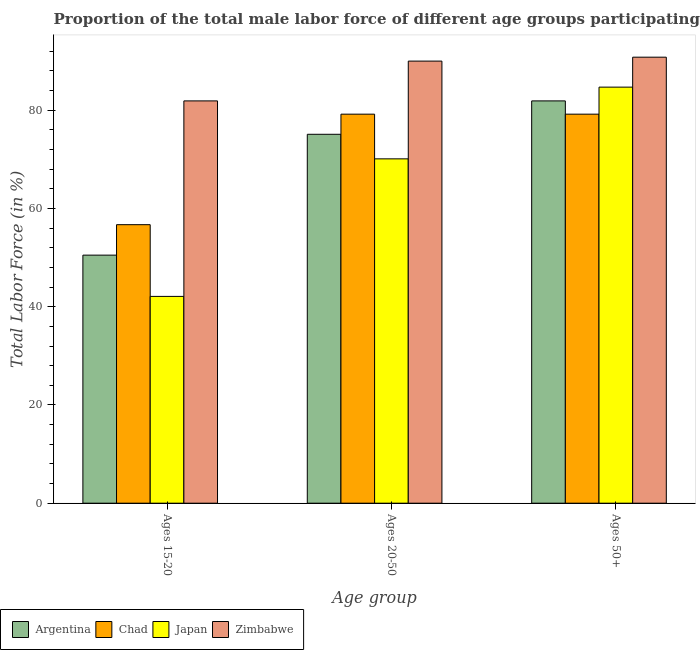How many groups of bars are there?
Provide a short and direct response. 3. Are the number of bars per tick equal to the number of legend labels?
Your answer should be compact. Yes. Are the number of bars on each tick of the X-axis equal?
Provide a succinct answer. Yes. What is the label of the 2nd group of bars from the left?
Provide a succinct answer. Ages 20-50. What is the percentage of male labor force above age 50 in Japan?
Keep it short and to the point. 84.7. Across all countries, what is the maximum percentage of male labor force within the age group 20-50?
Offer a very short reply. 90. Across all countries, what is the minimum percentage of male labor force within the age group 20-50?
Offer a very short reply. 70.1. In which country was the percentage of male labor force above age 50 maximum?
Provide a succinct answer. Zimbabwe. What is the total percentage of male labor force within the age group 15-20 in the graph?
Offer a terse response. 231.2. What is the difference between the percentage of male labor force above age 50 in Japan and that in Zimbabwe?
Your answer should be very brief. -6.1. What is the difference between the percentage of male labor force within the age group 15-20 in Zimbabwe and the percentage of male labor force within the age group 20-50 in Chad?
Provide a succinct answer. 2.7. What is the average percentage of male labor force within the age group 15-20 per country?
Ensure brevity in your answer.  57.8. What is the difference between the percentage of male labor force above age 50 and percentage of male labor force within the age group 20-50 in Japan?
Provide a succinct answer. 14.6. What is the ratio of the percentage of male labor force within the age group 15-20 in Argentina to that in Chad?
Ensure brevity in your answer.  0.89. Is the percentage of male labor force within the age group 20-50 in Argentina less than that in Japan?
Offer a very short reply. No. Is the difference between the percentage of male labor force within the age group 15-20 in Argentina and Chad greater than the difference between the percentage of male labor force above age 50 in Argentina and Chad?
Make the answer very short. No. What is the difference between the highest and the second highest percentage of male labor force above age 50?
Your answer should be compact. 6.1. What is the difference between the highest and the lowest percentage of male labor force above age 50?
Offer a very short reply. 11.6. In how many countries, is the percentage of male labor force within the age group 15-20 greater than the average percentage of male labor force within the age group 15-20 taken over all countries?
Your answer should be compact. 1. Is the sum of the percentage of male labor force within the age group 20-50 in Chad and Zimbabwe greater than the maximum percentage of male labor force above age 50 across all countries?
Provide a short and direct response. Yes. What does the 4th bar from the left in Ages 20-50 represents?
Your answer should be compact. Zimbabwe. What does the 1st bar from the right in Ages 15-20 represents?
Give a very brief answer. Zimbabwe. How many bars are there?
Your answer should be very brief. 12. Are all the bars in the graph horizontal?
Provide a short and direct response. No. How many countries are there in the graph?
Your response must be concise. 4. Are the values on the major ticks of Y-axis written in scientific E-notation?
Give a very brief answer. No. Does the graph contain grids?
Keep it short and to the point. No. Where does the legend appear in the graph?
Make the answer very short. Bottom left. What is the title of the graph?
Offer a very short reply. Proportion of the total male labor force of different age groups participating in production in 2014. What is the label or title of the X-axis?
Provide a succinct answer. Age group. What is the label or title of the Y-axis?
Provide a short and direct response. Total Labor Force (in %). What is the Total Labor Force (in %) in Argentina in Ages 15-20?
Your answer should be compact. 50.5. What is the Total Labor Force (in %) of Chad in Ages 15-20?
Your response must be concise. 56.7. What is the Total Labor Force (in %) of Japan in Ages 15-20?
Provide a succinct answer. 42.1. What is the Total Labor Force (in %) of Zimbabwe in Ages 15-20?
Provide a succinct answer. 81.9. What is the Total Labor Force (in %) in Argentina in Ages 20-50?
Give a very brief answer. 75.1. What is the Total Labor Force (in %) of Chad in Ages 20-50?
Your response must be concise. 79.2. What is the Total Labor Force (in %) in Japan in Ages 20-50?
Offer a very short reply. 70.1. What is the Total Labor Force (in %) of Zimbabwe in Ages 20-50?
Keep it short and to the point. 90. What is the Total Labor Force (in %) of Argentina in Ages 50+?
Keep it short and to the point. 81.9. What is the Total Labor Force (in %) in Chad in Ages 50+?
Give a very brief answer. 79.2. What is the Total Labor Force (in %) in Japan in Ages 50+?
Your answer should be very brief. 84.7. What is the Total Labor Force (in %) of Zimbabwe in Ages 50+?
Provide a short and direct response. 90.8. Across all Age group, what is the maximum Total Labor Force (in %) of Argentina?
Make the answer very short. 81.9. Across all Age group, what is the maximum Total Labor Force (in %) in Chad?
Keep it short and to the point. 79.2. Across all Age group, what is the maximum Total Labor Force (in %) of Japan?
Your answer should be very brief. 84.7. Across all Age group, what is the maximum Total Labor Force (in %) in Zimbabwe?
Ensure brevity in your answer.  90.8. Across all Age group, what is the minimum Total Labor Force (in %) in Argentina?
Give a very brief answer. 50.5. Across all Age group, what is the minimum Total Labor Force (in %) in Chad?
Ensure brevity in your answer.  56.7. Across all Age group, what is the minimum Total Labor Force (in %) in Japan?
Offer a terse response. 42.1. Across all Age group, what is the minimum Total Labor Force (in %) of Zimbabwe?
Offer a terse response. 81.9. What is the total Total Labor Force (in %) of Argentina in the graph?
Make the answer very short. 207.5. What is the total Total Labor Force (in %) in Chad in the graph?
Provide a succinct answer. 215.1. What is the total Total Labor Force (in %) of Japan in the graph?
Provide a succinct answer. 196.9. What is the total Total Labor Force (in %) in Zimbabwe in the graph?
Ensure brevity in your answer.  262.7. What is the difference between the Total Labor Force (in %) in Argentina in Ages 15-20 and that in Ages 20-50?
Ensure brevity in your answer.  -24.6. What is the difference between the Total Labor Force (in %) of Chad in Ages 15-20 and that in Ages 20-50?
Provide a succinct answer. -22.5. What is the difference between the Total Labor Force (in %) in Japan in Ages 15-20 and that in Ages 20-50?
Your answer should be very brief. -28. What is the difference between the Total Labor Force (in %) of Zimbabwe in Ages 15-20 and that in Ages 20-50?
Keep it short and to the point. -8.1. What is the difference between the Total Labor Force (in %) of Argentina in Ages 15-20 and that in Ages 50+?
Provide a short and direct response. -31.4. What is the difference between the Total Labor Force (in %) in Chad in Ages 15-20 and that in Ages 50+?
Your response must be concise. -22.5. What is the difference between the Total Labor Force (in %) in Japan in Ages 15-20 and that in Ages 50+?
Your answer should be very brief. -42.6. What is the difference between the Total Labor Force (in %) of Chad in Ages 20-50 and that in Ages 50+?
Offer a terse response. 0. What is the difference between the Total Labor Force (in %) in Japan in Ages 20-50 and that in Ages 50+?
Give a very brief answer. -14.6. What is the difference between the Total Labor Force (in %) of Argentina in Ages 15-20 and the Total Labor Force (in %) of Chad in Ages 20-50?
Provide a short and direct response. -28.7. What is the difference between the Total Labor Force (in %) in Argentina in Ages 15-20 and the Total Labor Force (in %) in Japan in Ages 20-50?
Keep it short and to the point. -19.6. What is the difference between the Total Labor Force (in %) in Argentina in Ages 15-20 and the Total Labor Force (in %) in Zimbabwe in Ages 20-50?
Provide a succinct answer. -39.5. What is the difference between the Total Labor Force (in %) in Chad in Ages 15-20 and the Total Labor Force (in %) in Zimbabwe in Ages 20-50?
Provide a succinct answer. -33.3. What is the difference between the Total Labor Force (in %) of Japan in Ages 15-20 and the Total Labor Force (in %) of Zimbabwe in Ages 20-50?
Your answer should be very brief. -47.9. What is the difference between the Total Labor Force (in %) of Argentina in Ages 15-20 and the Total Labor Force (in %) of Chad in Ages 50+?
Keep it short and to the point. -28.7. What is the difference between the Total Labor Force (in %) of Argentina in Ages 15-20 and the Total Labor Force (in %) of Japan in Ages 50+?
Your response must be concise. -34.2. What is the difference between the Total Labor Force (in %) in Argentina in Ages 15-20 and the Total Labor Force (in %) in Zimbabwe in Ages 50+?
Give a very brief answer. -40.3. What is the difference between the Total Labor Force (in %) of Chad in Ages 15-20 and the Total Labor Force (in %) of Zimbabwe in Ages 50+?
Your answer should be compact. -34.1. What is the difference between the Total Labor Force (in %) in Japan in Ages 15-20 and the Total Labor Force (in %) in Zimbabwe in Ages 50+?
Your answer should be compact. -48.7. What is the difference between the Total Labor Force (in %) of Argentina in Ages 20-50 and the Total Labor Force (in %) of Japan in Ages 50+?
Provide a succinct answer. -9.6. What is the difference between the Total Labor Force (in %) of Argentina in Ages 20-50 and the Total Labor Force (in %) of Zimbabwe in Ages 50+?
Your answer should be compact. -15.7. What is the difference between the Total Labor Force (in %) in Chad in Ages 20-50 and the Total Labor Force (in %) in Japan in Ages 50+?
Make the answer very short. -5.5. What is the difference between the Total Labor Force (in %) of Chad in Ages 20-50 and the Total Labor Force (in %) of Zimbabwe in Ages 50+?
Give a very brief answer. -11.6. What is the difference between the Total Labor Force (in %) of Japan in Ages 20-50 and the Total Labor Force (in %) of Zimbabwe in Ages 50+?
Give a very brief answer. -20.7. What is the average Total Labor Force (in %) in Argentina per Age group?
Make the answer very short. 69.17. What is the average Total Labor Force (in %) in Chad per Age group?
Offer a very short reply. 71.7. What is the average Total Labor Force (in %) in Japan per Age group?
Make the answer very short. 65.63. What is the average Total Labor Force (in %) in Zimbabwe per Age group?
Your response must be concise. 87.57. What is the difference between the Total Labor Force (in %) in Argentina and Total Labor Force (in %) in Chad in Ages 15-20?
Ensure brevity in your answer.  -6.2. What is the difference between the Total Labor Force (in %) of Argentina and Total Labor Force (in %) of Zimbabwe in Ages 15-20?
Give a very brief answer. -31.4. What is the difference between the Total Labor Force (in %) in Chad and Total Labor Force (in %) in Japan in Ages 15-20?
Provide a succinct answer. 14.6. What is the difference between the Total Labor Force (in %) in Chad and Total Labor Force (in %) in Zimbabwe in Ages 15-20?
Keep it short and to the point. -25.2. What is the difference between the Total Labor Force (in %) in Japan and Total Labor Force (in %) in Zimbabwe in Ages 15-20?
Your response must be concise. -39.8. What is the difference between the Total Labor Force (in %) of Argentina and Total Labor Force (in %) of Zimbabwe in Ages 20-50?
Keep it short and to the point. -14.9. What is the difference between the Total Labor Force (in %) in Japan and Total Labor Force (in %) in Zimbabwe in Ages 20-50?
Offer a very short reply. -19.9. What is the difference between the Total Labor Force (in %) in Argentina and Total Labor Force (in %) in Japan in Ages 50+?
Provide a short and direct response. -2.8. What is the difference between the Total Labor Force (in %) of Chad and Total Labor Force (in %) of Japan in Ages 50+?
Keep it short and to the point. -5.5. What is the difference between the Total Labor Force (in %) of Japan and Total Labor Force (in %) of Zimbabwe in Ages 50+?
Give a very brief answer. -6.1. What is the ratio of the Total Labor Force (in %) in Argentina in Ages 15-20 to that in Ages 20-50?
Ensure brevity in your answer.  0.67. What is the ratio of the Total Labor Force (in %) in Chad in Ages 15-20 to that in Ages 20-50?
Ensure brevity in your answer.  0.72. What is the ratio of the Total Labor Force (in %) of Japan in Ages 15-20 to that in Ages 20-50?
Make the answer very short. 0.6. What is the ratio of the Total Labor Force (in %) of Zimbabwe in Ages 15-20 to that in Ages 20-50?
Your response must be concise. 0.91. What is the ratio of the Total Labor Force (in %) of Argentina in Ages 15-20 to that in Ages 50+?
Your answer should be very brief. 0.62. What is the ratio of the Total Labor Force (in %) in Chad in Ages 15-20 to that in Ages 50+?
Offer a very short reply. 0.72. What is the ratio of the Total Labor Force (in %) of Japan in Ages 15-20 to that in Ages 50+?
Your answer should be compact. 0.5. What is the ratio of the Total Labor Force (in %) of Zimbabwe in Ages 15-20 to that in Ages 50+?
Give a very brief answer. 0.9. What is the ratio of the Total Labor Force (in %) of Argentina in Ages 20-50 to that in Ages 50+?
Make the answer very short. 0.92. What is the ratio of the Total Labor Force (in %) of Japan in Ages 20-50 to that in Ages 50+?
Offer a terse response. 0.83. What is the ratio of the Total Labor Force (in %) of Zimbabwe in Ages 20-50 to that in Ages 50+?
Offer a terse response. 0.99. What is the difference between the highest and the second highest Total Labor Force (in %) of Zimbabwe?
Offer a very short reply. 0.8. What is the difference between the highest and the lowest Total Labor Force (in %) in Argentina?
Keep it short and to the point. 31.4. What is the difference between the highest and the lowest Total Labor Force (in %) in Chad?
Offer a very short reply. 22.5. What is the difference between the highest and the lowest Total Labor Force (in %) of Japan?
Make the answer very short. 42.6. 